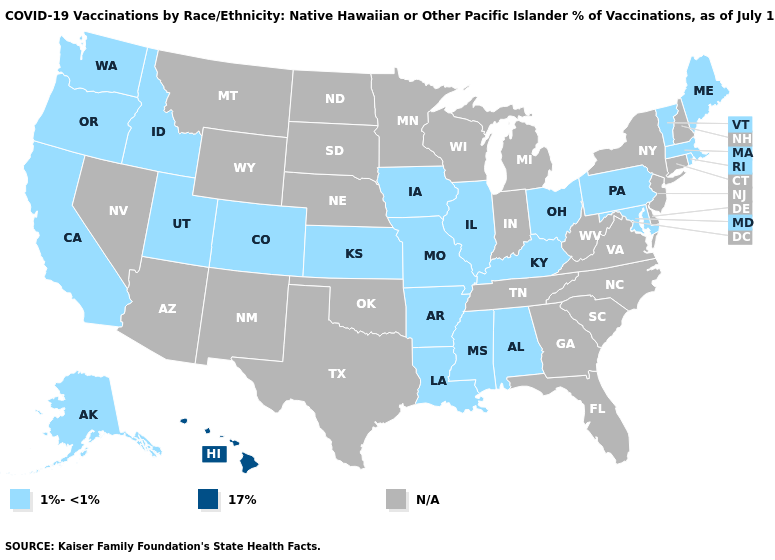What is the value of Massachusetts?
Concise answer only. 1%-<1%. Name the states that have a value in the range 17%?
Write a very short answer. Hawaii. What is the value of New York?
Short answer required. N/A. What is the value of Montana?
Give a very brief answer. N/A. What is the value of Utah?
Be succinct. 1%-<1%. What is the value of Oklahoma?
Keep it brief. N/A. What is the value of Kentucky?
Be succinct. 1%-<1%. What is the lowest value in states that border Nebraska?
Be succinct. 1%-<1%. Name the states that have a value in the range 17%?
Be succinct. Hawaii. Does the map have missing data?
Answer briefly. Yes. 